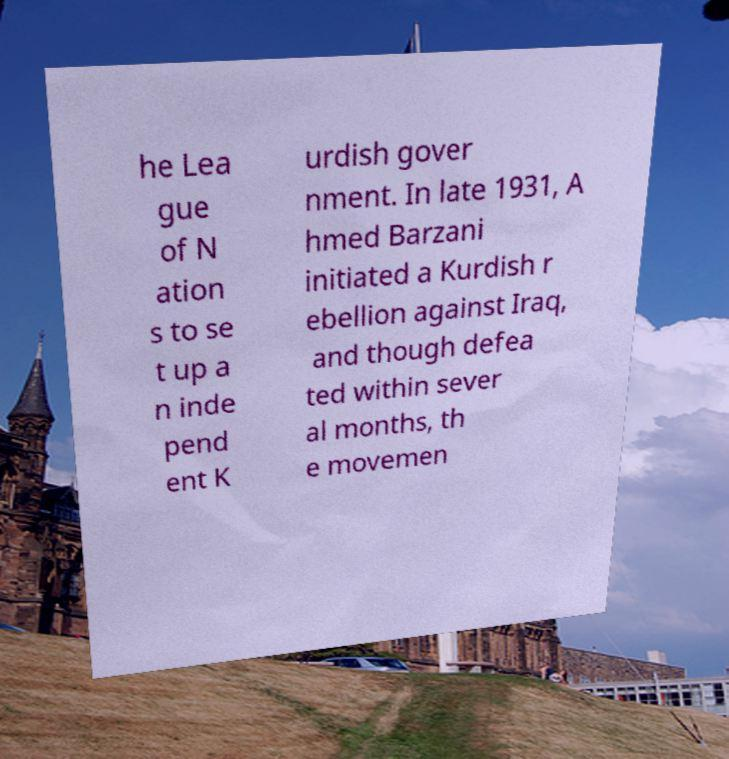Could you extract and type out the text from this image? he Lea gue of N ation s to se t up a n inde pend ent K urdish gover nment. In late 1931, A hmed Barzani initiated a Kurdish r ebellion against Iraq, and though defea ted within sever al months, th e movemen 